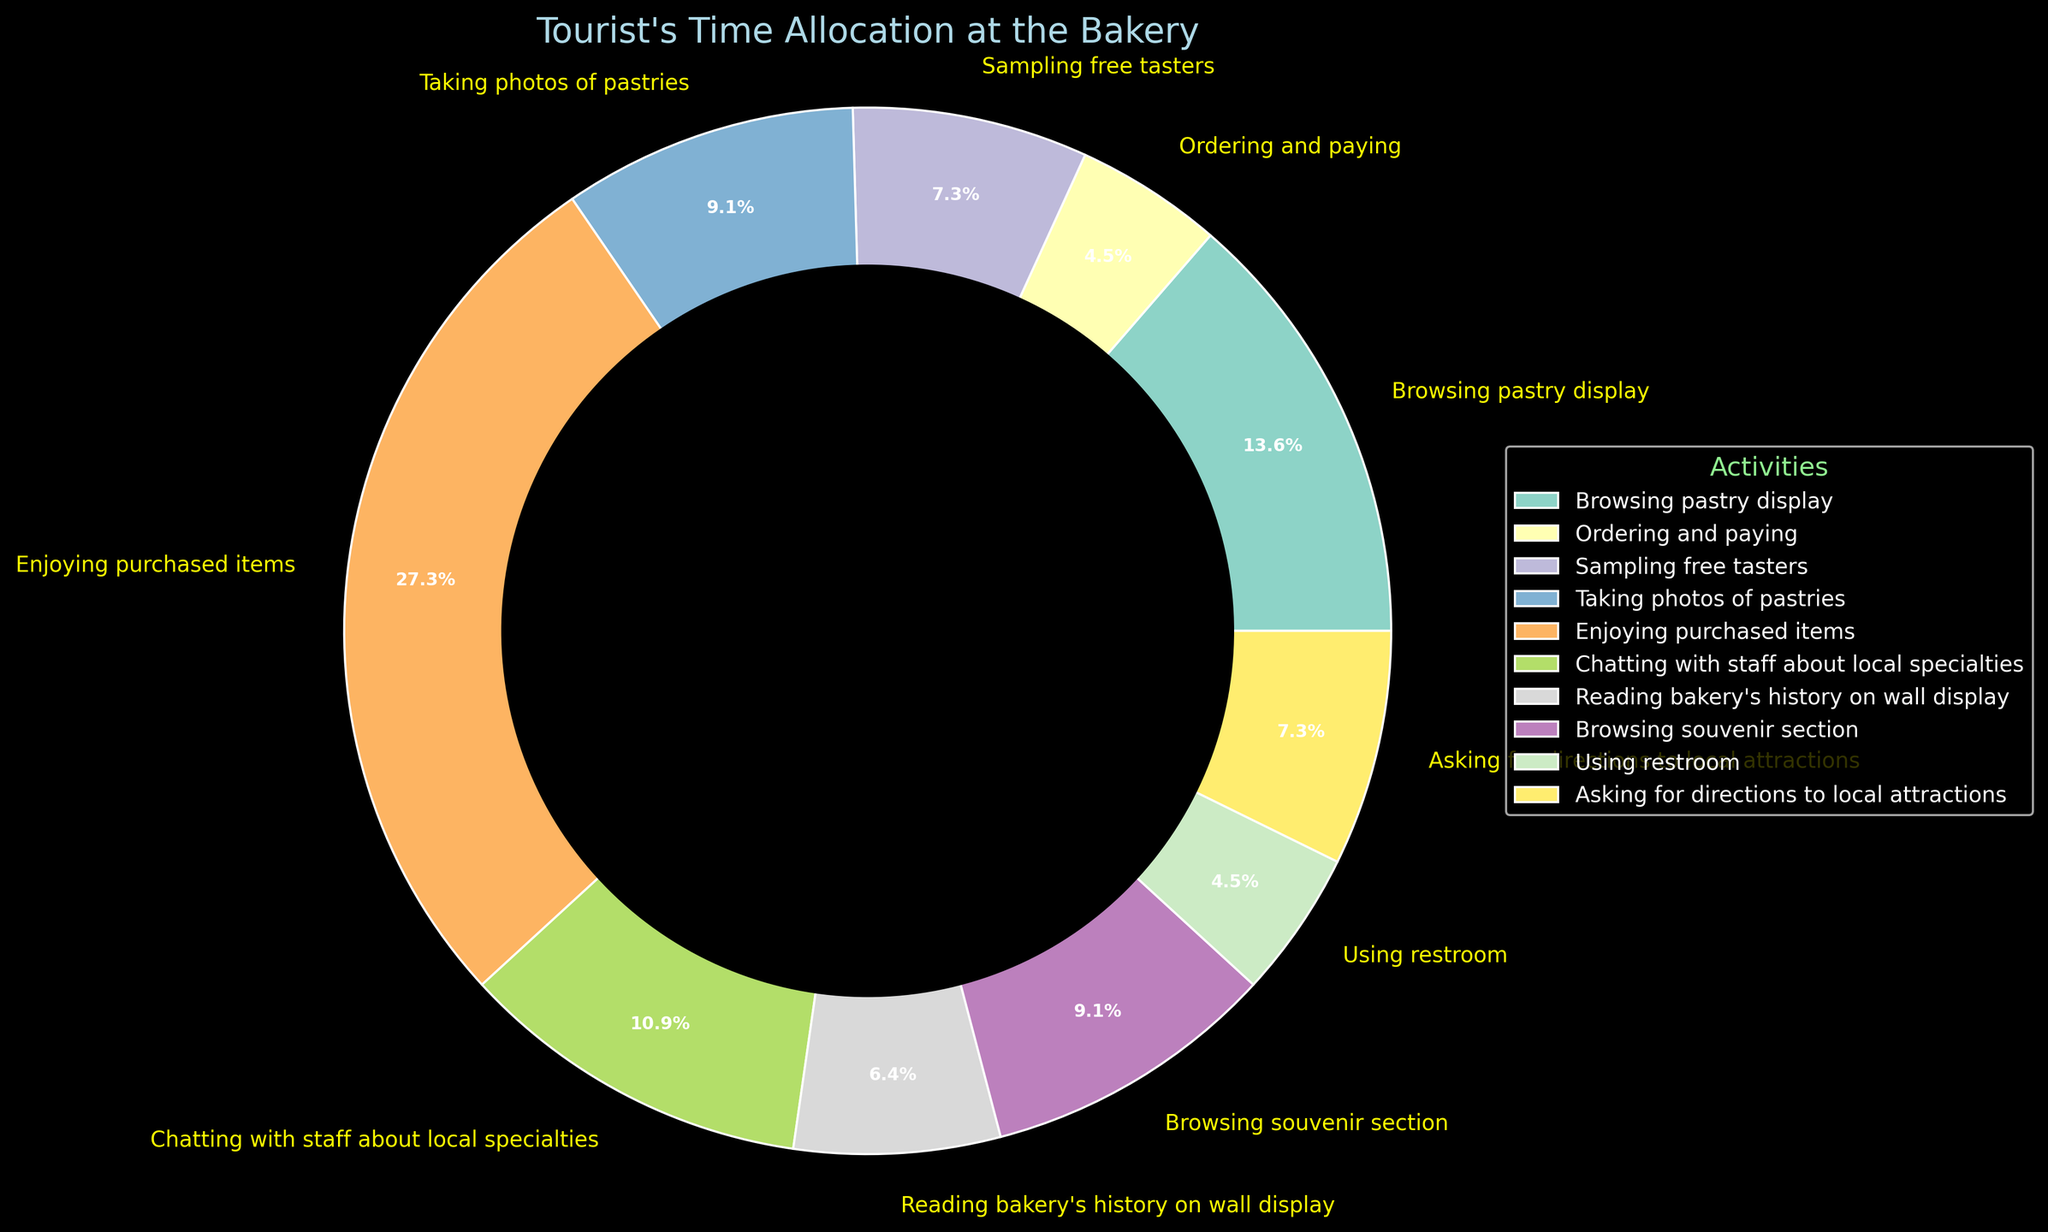What's the total amount of time spent on browsing-related activities? To determine the total time spent on browsing-related activities, we need to sum the time spent on "Browsing pastry display" and "Browsing souvenir section". They are 15 and 10 minutes, respectively. Adding them up, we get 15 + 10 = 25 minutes.
Answer: 25 minutes Which activity consumes the most time? To find the activity that consumes the most time, we need to compare the minutes spent on each activity. "Enjoying purchased items" has the highest time allocation at 30 minutes, as indicated on the pie chart.
Answer: Enjoying purchased items Do tourists spend more time sampling free tasters or asking for directions to local attractions? From the pie chart, the time spent on sampling free tasters is 8 minutes, and the time spent asking for directions to local attractions is also 8 minutes. Therefore, tourists spend an equal amount of time on both activities.
Answer: Equal What's the combined time spent on taking photos and chatting with staff? To find the combined time for taking photos and chatting with staff, we add the minutes allocated to both activities. "Taking photos of pastries" takes 10 minutes, and "Chatting with staff about local specialties" takes 12 minutes. The total is 10 + 12 = 22 minutes.
Answer: 22 minutes Which activity represented by the pie chart appears with the color closest to green? By examining the colors used in the pie chart, "Browsing souvenirs section" is represented in green.
Answer: Browsing souvenir section How much more time do tourists spend enjoying purchased items compared to ordering and paying? To determine how much more time is spent enjoying purchased items compared to ordering and paying, we subtract the time spent ordering and paying (5 minutes) from the time spent enjoying purchased items (30 minutes). So, 30 - 5 = 25 minutes more is spent enjoying purchased items.
Answer: 25 minutes What's the average time spent on all activities? To find the average time, we sum the minutes for all activities and divide by the number of activities. The total is 15 + 5 + 8 + 10 + 30 + 12 + 7 + 10 + 5 + 8 = 110 minutes. There are 10 activities, so the average time spent per activity is 110 / 10 = 11 minutes.
Answer: 11 minutes Which activity takes the least amount of time, and how much is it? By comparing the time allocation of all activities in the pie chart, the "Ordering and paying" activity takes the least amount of time at 5 minutes.
Answer: Ordering and paying, 5 minutes What's the difference in time spent between reading the bakery's history and using the restroom? We need to find the difference in time between "Reading bakery's history on wall display" (7 minutes) and "Using restroom" (5 minutes). The difference is 7 - 5 = 2 minutes.
Answer: 2 minutes Is the time spent taking photos of pastries closer to that of chatting with staff or to browsing the souvenir section? The time spent taking photos of pastries is 10 minutes. The time spent chatting with staff is 12 minutes, and browsing the souvenir section is 10 minutes. Therefore, the time spent taking photos is closer to that of browsing the souvenir section (10 minutes).
Answer: Browsing the souvenir section 